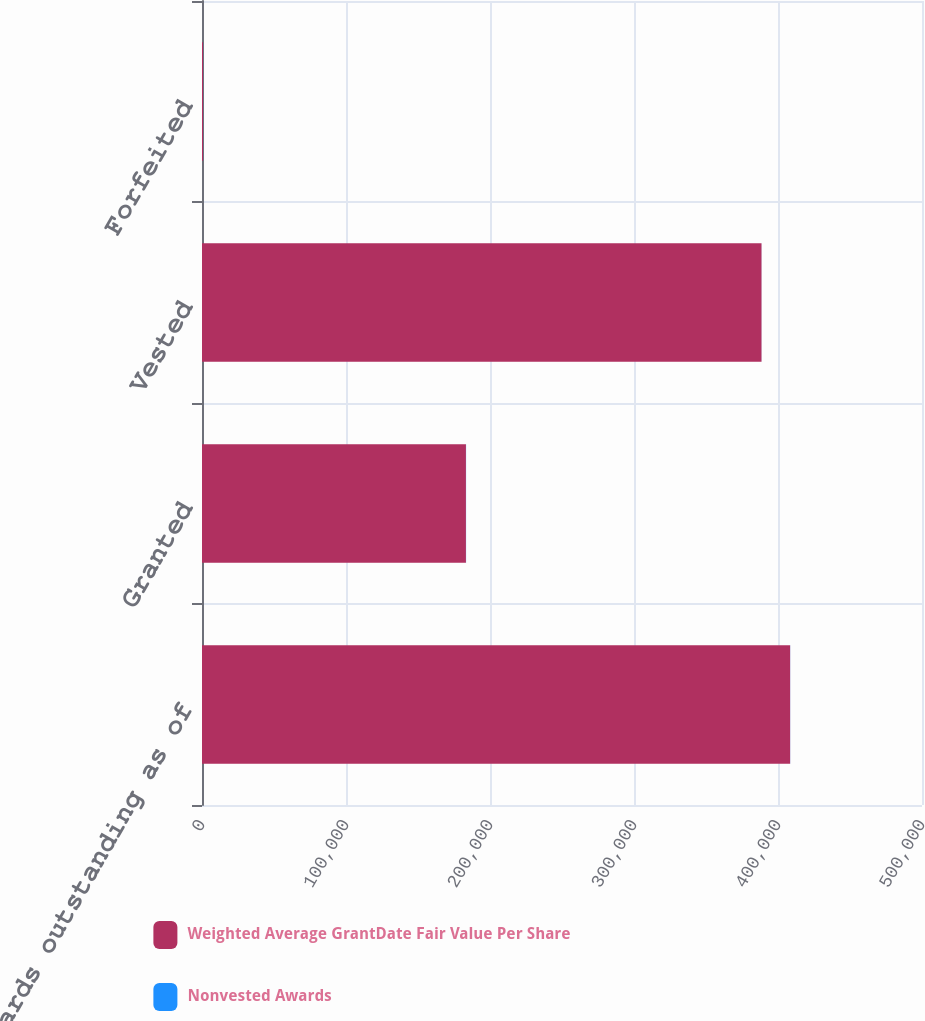Convert chart. <chart><loc_0><loc_0><loc_500><loc_500><stacked_bar_chart><ecel><fcel>Awards outstanding as of<fcel>Granted<fcel>Vested<fcel>Forfeited<nl><fcel>Weighted Average GrantDate Fair Value Per Share<fcel>408425<fcel>183299<fcel>388561<fcel>703<nl><fcel>Nonvested Awards<fcel>66.23<fcel>88.97<fcel>38.77<fcel>48.57<nl></chart> 